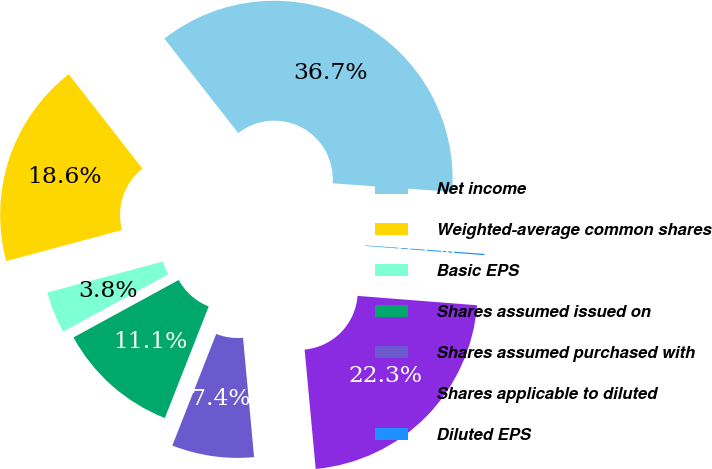Convert chart to OTSL. <chart><loc_0><loc_0><loc_500><loc_500><pie_chart><fcel>Net income<fcel>Weighted-average common shares<fcel>Basic EPS<fcel>Shares assumed issued on<fcel>Shares assumed purchased with<fcel>Shares applicable to diluted<fcel>Diluted EPS<nl><fcel>36.68%<fcel>18.62%<fcel>3.77%<fcel>11.09%<fcel>7.43%<fcel>22.28%<fcel>0.12%<nl></chart> 